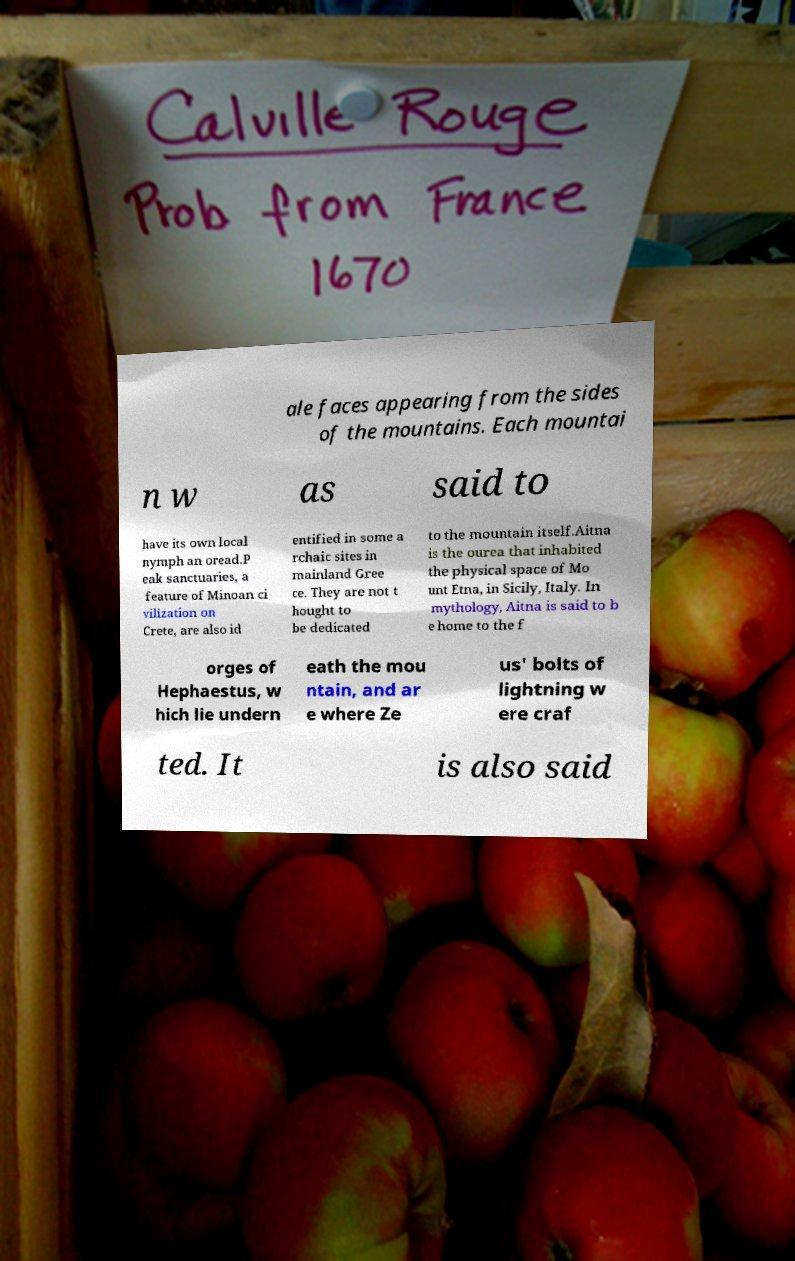Could you assist in decoding the text presented in this image and type it out clearly? ale faces appearing from the sides of the mountains. Each mountai n w as said to have its own local nymph an oread.P eak sanctuaries, a feature of Minoan ci vilization on Crete, are also id entified in some a rchaic sites in mainland Gree ce. They are not t hought to be dedicated to the mountain itself.Aitna is the ourea that inhabited the physical space of Mo unt Etna, in Sicily, Italy. In mythology, Aitna is said to b e home to the f orges of Hephaestus, w hich lie undern eath the mou ntain, and ar e where Ze us' bolts of lightning w ere craf ted. It is also said 